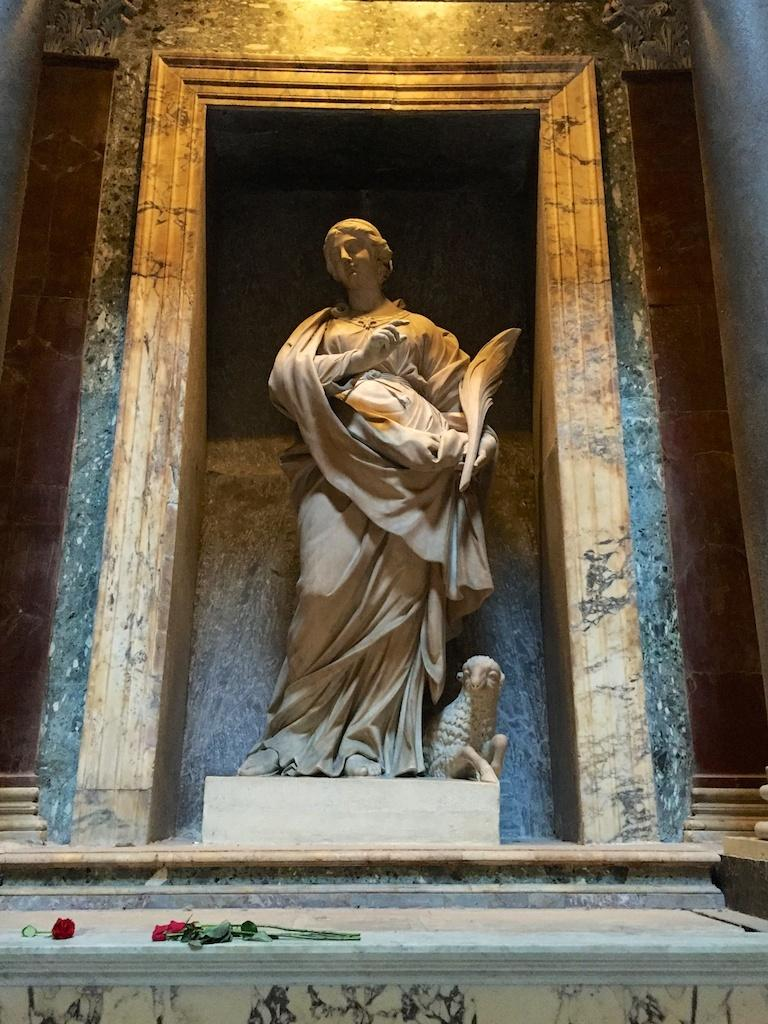What is the main subject in the middle of the image? There is a statue in the middle of the image. What can be seen in front of the statue? There are flowers in front of the statue. What type of bed is visible in the image? There is no bed present in the image; it features a statue with flowers in front of it. 